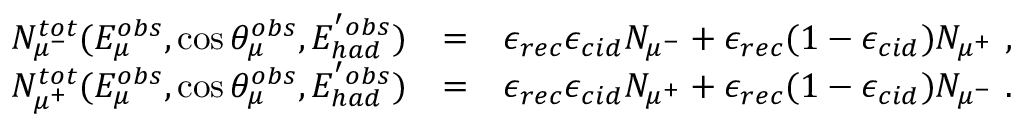Convert formula to latex. <formula><loc_0><loc_0><loc_500><loc_500>\begin{array} { r l r } { N _ { \mu ^ { - } } ^ { t o t } ( E _ { \mu } ^ { o b s } , \cos \theta _ { \mu } ^ { o b s } , E _ { h a d } ^ { ^ { \prime } o b s } ) } & { = } & { \epsilon _ { r e c } \epsilon _ { c i d } N _ { \mu ^ { - } } + \epsilon _ { r e c } ( 1 - \epsilon _ { c i d } ) N _ { \mu ^ { + } } , } \\ { N _ { \mu ^ { + } } ^ { t o t } ( E _ { \mu } ^ { o b s } , \cos \theta _ { \mu } ^ { o b s } , E _ { h a d } ^ { ^ { \prime } o b s } ) } & { = } & { \epsilon _ { r e c } \epsilon _ { c i d } N _ { \mu ^ { + } } + \epsilon _ { r e c } ( 1 - \epsilon _ { c i d } ) N _ { \mu ^ { - } } . } \end{array}</formula> 